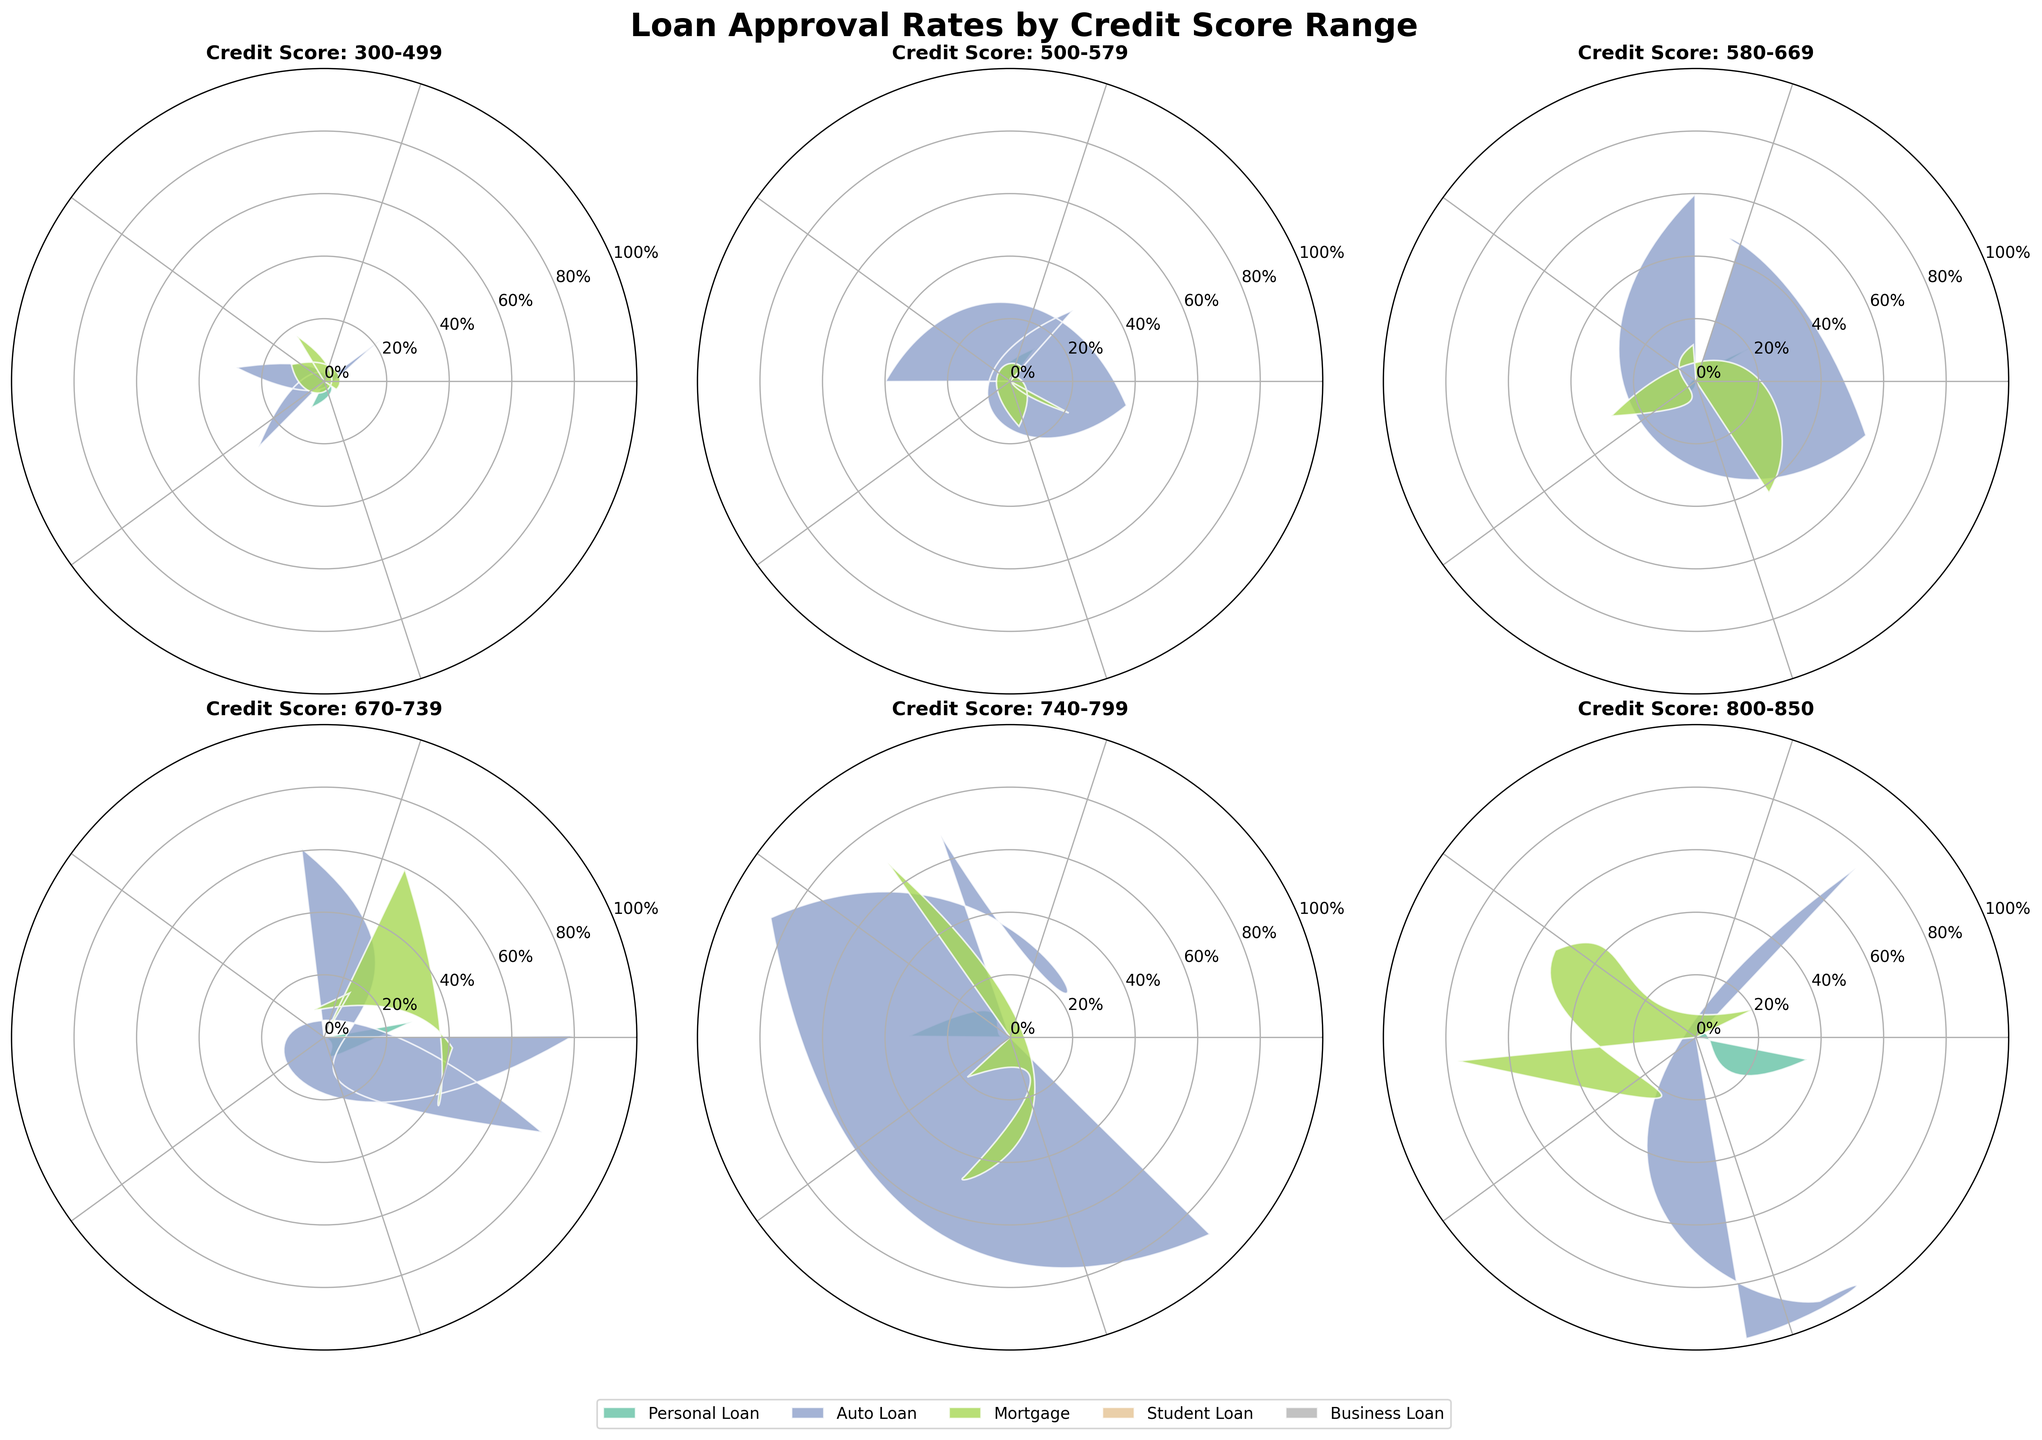What is the title of the chart? The title is located at the top center of the figure and summarizes the main subject of the chart.
Answer: Loan Approval Rates by Credit Score Range How many credit score ranges are depicted in the chart? Each subplot represents a different credit score range, and there are six subplots in total.
Answer: Six Which loan type has the highest approval rate for the 800-850 credit score range? In the subplot titled "Credit Score: 800-850," the loan type with the highest approval rate is Student Loan, which reaches nearly 100%.
Answer: Student Loan What is the overall trend in loan approval rates as the credit score range increases? By comparing subplots from lower to higher credit scores, loan approval rates from all loan types increase as the credit score range increases.
Answer: Loan approval rates increase Which credit score range has the lowest approval rate for Personal Loans? By examining each subplot, the 300-499 credit score range shows the lowest approval rate for Personal Loans at 25%.
Answer: 300-499 Calculate the average approval rate for Student Loans across all credit score ranges. Extracting the approval rates for Student Loans from each subplot: 35% (300-499), 45% (500-579), 65% (580-669), 85% (670-739), 95% (740-799), and 99% (800-850). The average is calculated as (35+45+65+85+95+99)/6.
Answer: 70.67% Which has the greater approval rate for Auto Loans: the 580-669 or 670-739 credit score range? Comparing the approval rates for Auto Loans in both subplots, 60% in 580-669 and 80% in 670-739, the latter is greater.
Answer: 670-739 Which loan type shows the most significant improvement in approval rate from the 500-579 to the 740-799 credit score range? Comparing all loan types, Student Loans have an increase from 45% to 95%, which is a 50% improvement—the highest among all loan types.
Answer: Student Loans Identify the credit score range where Mortgage loans and Business loans have the same approval rate. In the subplot titled "Credit Score: 500-579," both Mortgage loans and Business loans have approval rates of 28%.
Answer: 500-579 